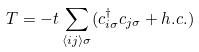<formula> <loc_0><loc_0><loc_500><loc_500>T = - t \sum _ { \langle i j \rangle \sigma } ( c ^ { \dagger } _ { i \sigma } c _ { j \sigma } + h . c . )</formula> 